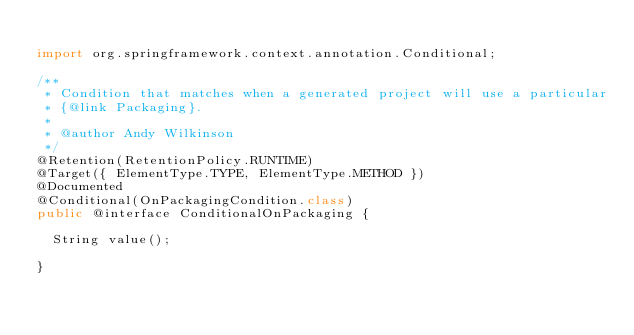<code> <loc_0><loc_0><loc_500><loc_500><_Java_>
import org.springframework.context.annotation.Conditional;

/**
 * Condition that matches when a generated project will use a particular
 * {@link Packaging}.
 *
 * @author Andy Wilkinson
 */
@Retention(RetentionPolicy.RUNTIME)
@Target({ ElementType.TYPE, ElementType.METHOD })
@Documented
@Conditional(OnPackagingCondition.class)
public @interface ConditionalOnPackaging {

	String value();

}
</code> 